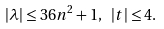<formula> <loc_0><loc_0><loc_500><loc_500>| \lambda | \leq 3 6 n ^ { 2 } + 1 , \ | t | \leq 4 .</formula> 